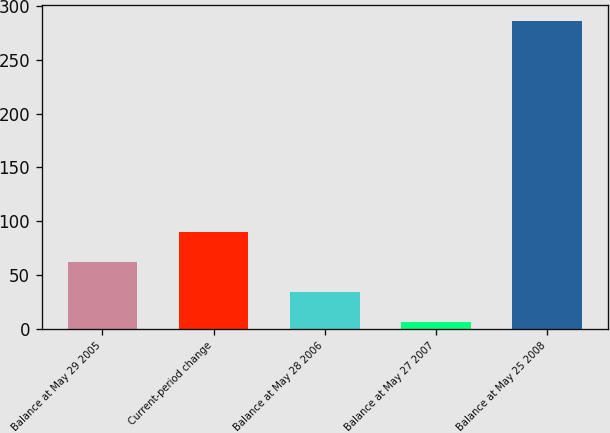<chart> <loc_0><loc_0><loc_500><loc_500><bar_chart><fcel>Balance at May 29 2005<fcel>Current-period change<fcel>Balance at May 28 2006<fcel>Balance at May 27 2007<fcel>Balance at May 25 2008<nl><fcel>62.02<fcel>90.08<fcel>33.96<fcel>5.9<fcel>286.5<nl></chart> 